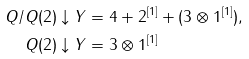<formula> <loc_0><loc_0><loc_500><loc_500>Q / Q ( 2 ) \downarrow Y & = 4 + 2 ^ { [ 1 ] } + ( 3 \otimes 1 ^ { [ 1 ] } ) , \\ Q ( 2 ) \downarrow Y & = 3 \otimes 1 ^ { [ 1 ] }</formula> 